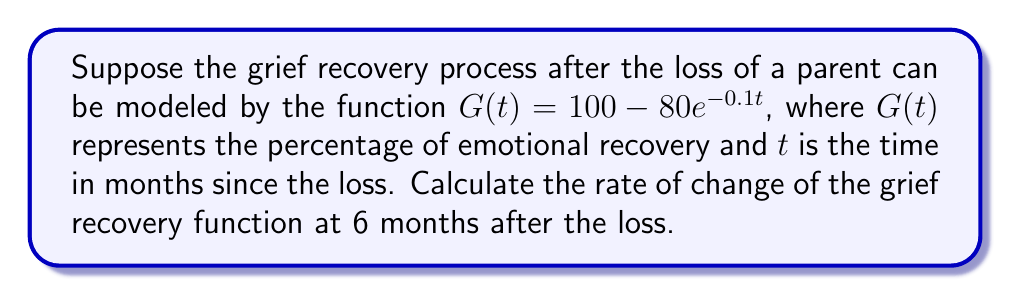What is the answer to this math problem? To find the rate of change of the grief recovery function at 6 months, we need to calculate the derivative of $G(t)$ and evaluate it at $t = 6$.

Step 1: Find the derivative of $G(t)$.
$$\frac{d}{dt}G(t) = \frac{d}{dt}(100 - 80e^{-0.1t})$$
$$G'(t) = 0 - 80 \cdot (-0.1)e^{-0.1t}$$
$$G'(t) = 8e^{-0.1t}$$

Step 2: Evaluate $G'(t)$ at $t = 6$.
$$G'(6) = 8e^{-0.1(6)}$$
$$G'(6) = 8e^{-0.6}$$
$$G'(6) = 8 \cdot 0.5488$$
$$G'(6) = 4.3904$$

Step 3: Interpret the result.
The rate of change at 6 months is approximately 4.3904 percentage points per month. This means that at the 6-month mark, the emotional recovery is increasing at a rate of about 4.39% per month.
Answer: $4.3904$ percentage points per month 